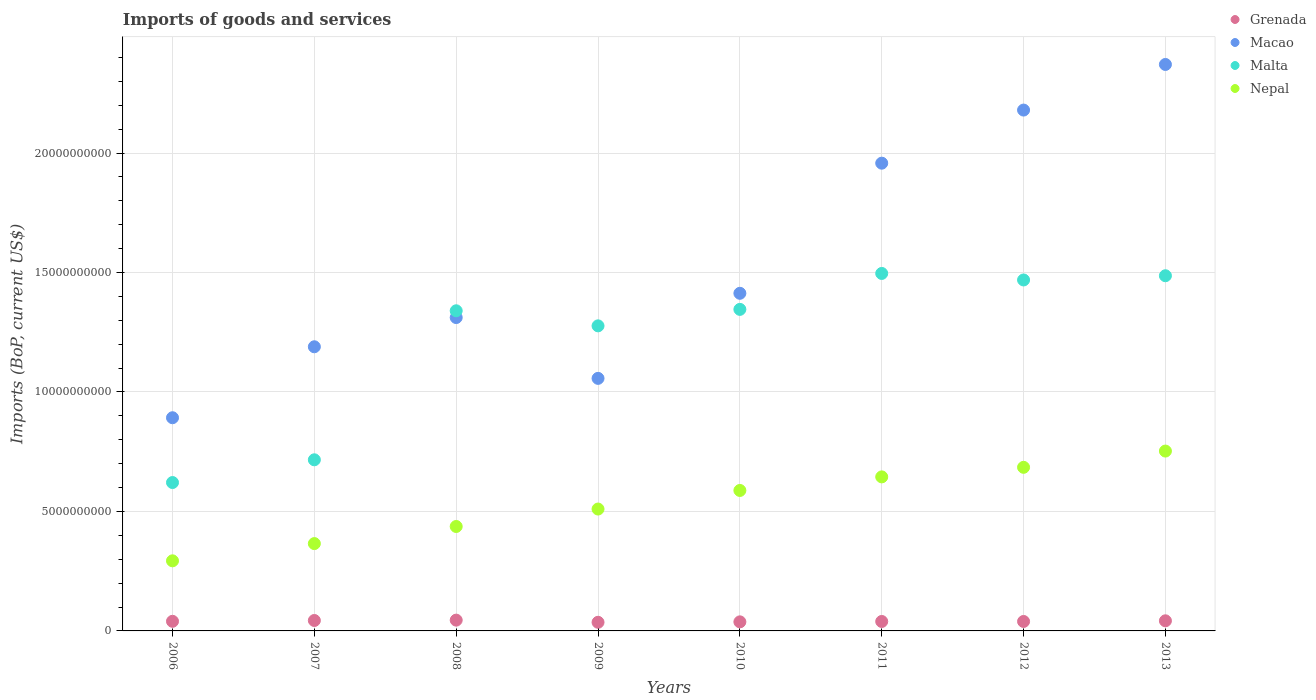Is the number of dotlines equal to the number of legend labels?
Give a very brief answer. Yes. What is the amount spent on imports in Macao in 2006?
Your answer should be compact. 8.92e+09. Across all years, what is the maximum amount spent on imports in Grenada?
Keep it short and to the point. 4.52e+08. Across all years, what is the minimum amount spent on imports in Macao?
Provide a short and direct response. 8.92e+09. In which year was the amount spent on imports in Macao maximum?
Give a very brief answer. 2013. What is the total amount spent on imports in Malta in the graph?
Offer a terse response. 9.75e+1. What is the difference between the amount spent on imports in Malta in 2008 and that in 2011?
Your response must be concise. -1.56e+09. What is the difference between the amount spent on imports in Nepal in 2011 and the amount spent on imports in Malta in 2013?
Provide a succinct answer. -8.42e+09. What is the average amount spent on imports in Malta per year?
Offer a terse response. 1.22e+1. In the year 2007, what is the difference between the amount spent on imports in Macao and amount spent on imports in Malta?
Keep it short and to the point. 4.73e+09. What is the ratio of the amount spent on imports in Grenada in 2010 to that in 2012?
Offer a terse response. 0.96. Is the amount spent on imports in Malta in 2008 less than that in 2012?
Provide a short and direct response. Yes. Is the difference between the amount spent on imports in Macao in 2008 and 2011 greater than the difference between the amount spent on imports in Malta in 2008 and 2011?
Ensure brevity in your answer.  No. What is the difference between the highest and the second highest amount spent on imports in Malta?
Provide a succinct answer. 9.62e+07. What is the difference between the highest and the lowest amount spent on imports in Malta?
Your response must be concise. 8.75e+09. Is it the case that in every year, the sum of the amount spent on imports in Grenada and amount spent on imports in Nepal  is greater than the amount spent on imports in Malta?
Ensure brevity in your answer.  No. Does the amount spent on imports in Malta monotonically increase over the years?
Give a very brief answer. No. What is the difference between two consecutive major ticks on the Y-axis?
Provide a succinct answer. 5.00e+09. Does the graph contain any zero values?
Your response must be concise. No. How are the legend labels stacked?
Make the answer very short. Vertical. What is the title of the graph?
Give a very brief answer. Imports of goods and services. What is the label or title of the Y-axis?
Your answer should be compact. Imports (BoP, current US$). What is the Imports (BoP, current US$) of Grenada in 2006?
Make the answer very short. 4.02e+08. What is the Imports (BoP, current US$) in Macao in 2006?
Your response must be concise. 8.92e+09. What is the Imports (BoP, current US$) in Malta in 2006?
Provide a short and direct response. 6.21e+09. What is the Imports (BoP, current US$) in Nepal in 2006?
Give a very brief answer. 2.93e+09. What is the Imports (BoP, current US$) in Grenada in 2007?
Ensure brevity in your answer.  4.36e+08. What is the Imports (BoP, current US$) in Macao in 2007?
Your answer should be compact. 1.19e+1. What is the Imports (BoP, current US$) in Malta in 2007?
Give a very brief answer. 7.16e+09. What is the Imports (BoP, current US$) of Nepal in 2007?
Provide a succinct answer. 3.66e+09. What is the Imports (BoP, current US$) of Grenada in 2008?
Provide a succinct answer. 4.52e+08. What is the Imports (BoP, current US$) in Macao in 2008?
Ensure brevity in your answer.  1.31e+1. What is the Imports (BoP, current US$) of Malta in 2008?
Keep it short and to the point. 1.34e+1. What is the Imports (BoP, current US$) in Nepal in 2008?
Your answer should be compact. 4.37e+09. What is the Imports (BoP, current US$) of Grenada in 2009?
Provide a short and direct response. 3.61e+08. What is the Imports (BoP, current US$) of Macao in 2009?
Make the answer very short. 1.06e+1. What is the Imports (BoP, current US$) of Malta in 2009?
Ensure brevity in your answer.  1.28e+1. What is the Imports (BoP, current US$) of Nepal in 2009?
Offer a terse response. 5.10e+09. What is the Imports (BoP, current US$) of Grenada in 2010?
Keep it short and to the point. 3.80e+08. What is the Imports (BoP, current US$) in Macao in 2010?
Your answer should be compact. 1.41e+1. What is the Imports (BoP, current US$) of Malta in 2010?
Provide a short and direct response. 1.35e+1. What is the Imports (BoP, current US$) of Nepal in 2010?
Your answer should be compact. 5.88e+09. What is the Imports (BoP, current US$) in Grenada in 2011?
Your response must be concise. 3.95e+08. What is the Imports (BoP, current US$) of Macao in 2011?
Give a very brief answer. 1.96e+1. What is the Imports (BoP, current US$) in Malta in 2011?
Provide a succinct answer. 1.50e+1. What is the Imports (BoP, current US$) of Nepal in 2011?
Keep it short and to the point. 6.45e+09. What is the Imports (BoP, current US$) of Grenada in 2012?
Offer a very short reply. 3.96e+08. What is the Imports (BoP, current US$) of Macao in 2012?
Offer a terse response. 2.18e+1. What is the Imports (BoP, current US$) in Malta in 2012?
Provide a succinct answer. 1.47e+1. What is the Imports (BoP, current US$) in Nepal in 2012?
Ensure brevity in your answer.  6.85e+09. What is the Imports (BoP, current US$) of Grenada in 2013?
Offer a very short reply. 4.23e+08. What is the Imports (BoP, current US$) of Macao in 2013?
Offer a terse response. 2.37e+1. What is the Imports (BoP, current US$) of Malta in 2013?
Ensure brevity in your answer.  1.49e+1. What is the Imports (BoP, current US$) of Nepal in 2013?
Your answer should be compact. 7.53e+09. Across all years, what is the maximum Imports (BoP, current US$) of Grenada?
Give a very brief answer. 4.52e+08. Across all years, what is the maximum Imports (BoP, current US$) of Macao?
Offer a terse response. 2.37e+1. Across all years, what is the maximum Imports (BoP, current US$) of Malta?
Keep it short and to the point. 1.50e+1. Across all years, what is the maximum Imports (BoP, current US$) in Nepal?
Offer a terse response. 7.53e+09. Across all years, what is the minimum Imports (BoP, current US$) in Grenada?
Ensure brevity in your answer.  3.61e+08. Across all years, what is the minimum Imports (BoP, current US$) in Macao?
Ensure brevity in your answer.  8.92e+09. Across all years, what is the minimum Imports (BoP, current US$) of Malta?
Offer a terse response. 6.21e+09. Across all years, what is the minimum Imports (BoP, current US$) of Nepal?
Give a very brief answer. 2.93e+09. What is the total Imports (BoP, current US$) of Grenada in the graph?
Your response must be concise. 3.25e+09. What is the total Imports (BoP, current US$) of Macao in the graph?
Your answer should be compact. 1.24e+11. What is the total Imports (BoP, current US$) of Malta in the graph?
Your answer should be compact. 9.75e+1. What is the total Imports (BoP, current US$) of Nepal in the graph?
Give a very brief answer. 4.28e+1. What is the difference between the Imports (BoP, current US$) in Grenada in 2006 and that in 2007?
Your response must be concise. -3.40e+07. What is the difference between the Imports (BoP, current US$) of Macao in 2006 and that in 2007?
Offer a terse response. -2.97e+09. What is the difference between the Imports (BoP, current US$) of Malta in 2006 and that in 2007?
Give a very brief answer. -9.52e+08. What is the difference between the Imports (BoP, current US$) in Nepal in 2006 and that in 2007?
Ensure brevity in your answer.  -7.21e+08. What is the difference between the Imports (BoP, current US$) of Grenada in 2006 and that in 2008?
Provide a short and direct response. -4.93e+07. What is the difference between the Imports (BoP, current US$) of Macao in 2006 and that in 2008?
Provide a short and direct response. -4.19e+09. What is the difference between the Imports (BoP, current US$) of Malta in 2006 and that in 2008?
Provide a short and direct response. -7.19e+09. What is the difference between the Imports (BoP, current US$) of Nepal in 2006 and that in 2008?
Provide a short and direct response. -1.44e+09. What is the difference between the Imports (BoP, current US$) in Grenada in 2006 and that in 2009?
Provide a short and direct response. 4.14e+07. What is the difference between the Imports (BoP, current US$) of Macao in 2006 and that in 2009?
Ensure brevity in your answer.  -1.65e+09. What is the difference between the Imports (BoP, current US$) in Malta in 2006 and that in 2009?
Make the answer very short. -6.56e+09. What is the difference between the Imports (BoP, current US$) in Nepal in 2006 and that in 2009?
Keep it short and to the point. -2.17e+09. What is the difference between the Imports (BoP, current US$) in Grenada in 2006 and that in 2010?
Make the answer very short. 2.28e+07. What is the difference between the Imports (BoP, current US$) of Macao in 2006 and that in 2010?
Your answer should be compact. -5.21e+09. What is the difference between the Imports (BoP, current US$) of Malta in 2006 and that in 2010?
Your response must be concise. -7.25e+09. What is the difference between the Imports (BoP, current US$) in Nepal in 2006 and that in 2010?
Provide a succinct answer. -2.94e+09. What is the difference between the Imports (BoP, current US$) in Grenada in 2006 and that in 2011?
Offer a terse response. 6.90e+06. What is the difference between the Imports (BoP, current US$) of Macao in 2006 and that in 2011?
Make the answer very short. -1.07e+1. What is the difference between the Imports (BoP, current US$) in Malta in 2006 and that in 2011?
Provide a succinct answer. -8.75e+09. What is the difference between the Imports (BoP, current US$) in Nepal in 2006 and that in 2011?
Your answer should be very brief. -3.51e+09. What is the difference between the Imports (BoP, current US$) in Grenada in 2006 and that in 2012?
Your answer should be compact. 6.71e+06. What is the difference between the Imports (BoP, current US$) in Macao in 2006 and that in 2012?
Make the answer very short. -1.29e+1. What is the difference between the Imports (BoP, current US$) in Malta in 2006 and that in 2012?
Offer a very short reply. -8.48e+09. What is the difference between the Imports (BoP, current US$) of Nepal in 2006 and that in 2012?
Offer a terse response. -3.91e+09. What is the difference between the Imports (BoP, current US$) of Grenada in 2006 and that in 2013?
Your response must be concise. -2.08e+07. What is the difference between the Imports (BoP, current US$) in Macao in 2006 and that in 2013?
Offer a terse response. -1.48e+1. What is the difference between the Imports (BoP, current US$) in Malta in 2006 and that in 2013?
Offer a very short reply. -8.66e+09. What is the difference between the Imports (BoP, current US$) of Nepal in 2006 and that in 2013?
Ensure brevity in your answer.  -4.59e+09. What is the difference between the Imports (BoP, current US$) of Grenada in 2007 and that in 2008?
Offer a terse response. -1.53e+07. What is the difference between the Imports (BoP, current US$) in Macao in 2007 and that in 2008?
Provide a succinct answer. -1.22e+09. What is the difference between the Imports (BoP, current US$) in Malta in 2007 and that in 2008?
Ensure brevity in your answer.  -6.24e+09. What is the difference between the Imports (BoP, current US$) in Nepal in 2007 and that in 2008?
Provide a short and direct response. -7.16e+08. What is the difference between the Imports (BoP, current US$) of Grenada in 2007 and that in 2009?
Your answer should be very brief. 7.54e+07. What is the difference between the Imports (BoP, current US$) in Macao in 2007 and that in 2009?
Offer a very short reply. 1.32e+09. What is the difference between the Imports (BoP, current US$) in Malta in 2007 and that in 2009?
Give a very brief answer. -5.61e+09. What is the difference between the Imports (BoP, current US$) in Nepal in 2007 and that in 2009?
Make the answer very short. -1.45e+09. What is the difference between the Imports (BoP, current US$) of Grenada in 2007 and that in 2010?
Your response must be concise. 5.68e+07. What is the difference between the Imports (BoP, current US$) in Macao in 2007 and that in 2010?
Provide a succinct answer. -2.24e+09. What is the difference between the Imports (BoP, current US$) in Malta in 2007 and that in 2010?
Provide a short and direct response. -6.30e+09. What is the difference between the Imports (BoP, current US$) in Nepal in 2007 and that in 2010?
Offer a very short reply. -2.22e+09. What is the difference between the Imports (BoP, current US$) in Grenada in 2007 and that in 2011?
Your answer should be very brief. 4.09e+07. What is the difference between the Imports (BoP, current US$) in Macao in 2007 and that in 2011?
Ensure brevity in your answer.  -7.68e+09. What is the difference between the Imports (BoP, current US$) in Malta in 2007 and that in 2011?
Provide a succinct answer. -7.80e+09. What is the difference between the Imports (BoP, current US$) in Nepal in 2007 and that in 2011?
Your answer should be compact. -2.79e+09. What is the difference between the Imports (BoP, current US$) in Grenada in 2007 and that in 2012?
Provide a short and direct response. 4.07e+07. What is the difference between the Imports (BoP, current US$) in Macao in 2007 and that in 2012?
Offer a terse response. -9.91e+09. What is the difference between the Imports (BoP, current US$) in Malta in 2007 and that in 2012?
Make the answer very short. -7.53e+09. What is the difference between the Imports (BoP, current US$) in Nepal in 2007 and that in 2012?
Your response must be concise. -3.19e+09. What is the difference between the Imports (BoP, current US$) in Grenada in 2007 and that in 2013?
Keep it short and to the point. 1.32e+07. What is the difference between the Imports (BoP, current US$) of Macao in 2007 and that in 2013?
Ensure brevity in your answer.  -1.18e+1. What is the difference between the Imports (BoP, current US$) of Malta in 2007 and that in 2013?
Ensure brevity in your answer.  -7.70e+09. What is the difference between the Imports (BoP, current US$) of Nepal in 2007 and that in 2013?
Provide a succinct answer. -3.87e+09. What is the difference between the Imports (BoP, current US$) in Grenada in 2008 and that in 2009?
Ensure brevity in your answer.  9.08e+07. What is the difference between the Imports (BoP, current US$) of Macao in 2008 and that in 2009?
Offer a terse response. 2.55e+09. What is the difference between the Imports (BoP, current US$) in Malta in 2008 and that in 2009?
Make the answer very short. 6.31e+08. What is the difference between the Imports (BoP, current US$) of Nepal in 2008 and that in 2009?
Give a very brief answer. -7.30e+08. What is the difference between the Imports (BoP, current US$) of Grenada in 2008 and that in 2010?
Give a very brief answer. 7.22e+07. What is the difference between the Imports (BoP, current US$) of Macao in 2008 and that in 2010?
Offer a terse response. -1.01e+09. What is the difference between the Imports (BoP, current US$) of Malta in 2008 and that in 2010?
Offer a terse response. -5.88e+07. What is the difference between the Imports (BoP, current US$) of Nepal in 2008 and that in 2010?
Keep it short and to the point. -1.51e+09. What is the difference between the Imports (BoP, current US$) in Grenada in 2008 and that in 2011?
Ensure brevity in your answer.  5.62e+07. What is the difference between the Imports (BoP, current US$) in Macao in 2008 and that in 2011?
Your response must be concise. -6.46e+09. What is the difference between the Imports (BoP, current US$) in Malta in 2008 and that in 2011?
Provide a short and direct response. -1.56e+09. What is the difference between the Imports (BoP, current US$) of Nepal in 2008 and that in 2011?
Offer a very short reply. -2.08e+09. What is the difference between the Imports (BoP, current US$) of Grenada in 2008 and that in 2012?
Offer a terse response. 5.60e+07. What is the difference between the Imports (BoP, current US$) in Macao in 2008 and that in 2012?
Provide a succinct answer. -8.68e+09. What is the difference between the Imports (BoP, current US$) in Malta in 2008 and that in 2012?
Your response must be concise. -1.29e+09. What is the difference between the Imports (BoP, current US$) in Nepal in 2008 and that in 2012?
Offer a very short reply. -2.48e+09. What is the difference between the Imports (BoP, current US$) of Grenada in 2008 and that in 2013?
Your answer should be compact. 2.85e+07. What is the difference between the Imports (BoP, current US$) of Macao in 2008 and that in 2013?
Ensure brevity in your answer.  -1.06e+1. What is the difference between the Imports (BoP, current US$) of Malta in 2008 and that in 2013?
Your answer should be very brief. -1.47e+09. What is the difference between the Imports (BoP, current US$) of Nepal in 2008 and that in 2013?
Make the answer very short. -3.16e+09. What is the difference between the Imports (BoP, current US$) of Grenada in 2009 and that in 2010?
Your answer should be very brief. -1.86e+07. What is the difference between the Imports (BoP, current US$) of Macao in 2009 and that in 2010?
Your response must be concise. -3.56e+09. What is the difference between the Imports (BoP, current US$) in Malta in 2009 and that in 2010?
Provide a succinct answer. -6.89e+08. What is the difference between the Imports (BoP, current US$) in Nepal in 2009 and that in 2010?
Your answer should be compact. -7.78e+08. What is the difference between the Imports (BoP, current US$) in Grenada in 2009 and that in 2011?
Your answer should be very brief. -3.45e+07. What is the difference between the Imports (BoP, current US$) in Macao in 2009 and that in 2011?
Your response must be concise. -9.01e+09. What is the difference between the Imports (BoP, current US$) of Malta in 2009 and that in 2011?
Provide a succinct answer. -2.19e+09. What is the difference between the Imports (BoP, current US$) in Nepal in 2009 and that in 2011?
Your answer should be very brief. -1.35e+09. What is the difference between the Imports (BoP, current US$) of Grenada in 2009 and that in 2012?
Provide a short and direct response. -3.47e+07. What is the difference between the Imports (BoP, current US$) in Macao in 2009 and that in 2012?
Your answer should be very brief. -1.12e+1. What is the difference between the Imports (BoP, current US$) of Malta in 2009 and that in 2012?
Your answer should be compact. -1.92e+09. What is the difference between the Imports (BoP, current US$) in Nepal in 2009 and that in 2012?
Your answer should be very brief. -1.75e+09. What is the difference between the Imports (BoP, current US$) in Grenada in 2009 and that in 2013?
Your response must be concise. -6.23e+07. What is the difference between the Imports (BoP, current US$) of Macao in 2009 and that in 2013?
Provide a succinct answer. -1.31e+1. What is the difference between the Imports (BoP, current US$) in Malta in 2009 and that in 2013?
Offer a very short reply. -2.10e+09. What is the difference between the Imports (BoP, current US$) of Nepal in 2009 and that in 2013?
Make the answer very short. -2.43e+09. What is the difference between the Imports (BoP, current US$) in Grenada in 2010 and that in 2011?
Provide a succinct answer. -1.59e+07. What is the difference between the Imports (BoP, current US$) in Macao in 2010 and that in 2011?
Offer a terse response. -5.45e+09. What is the difference between the Imports (BoP, current US$) of Malta in 2010 and that in 2011?
Provide a short and direct response. -1.50e+09. What is the difference between the Imports (BoP, current US$) of Nepal in 2010 and that in 2011?
Provide a short and direct response. -5.68e+08. What is the difference between the Imports (BoP, current US$) of Grenada in 2010 and that in 2012?
Ensure brevity in your answer.  -1.61e+07. What is the difference between the Imports (BoP, current US$) of Macao in 2010 and that in 2012?
Make the answer very short. -7.67e+09. What is the difference between the Imports (BoP, current US$) in Malta in 2010 and that in 2012?
Offer a very short reply. -1.23e+09. What is the difference between the Imports (BoP, current US$) of Nepal in 2010 and that in 2012?
Ensure brevity in your answer.  -9.69e+08. What is the difference between the Imports (BoP, current US$) of Grenada in 2010 and that in 2013?
Your answer should be compact. -4.37e+07. What is the difference between the Imports (BoP, current US$) of Macao in 2010 and that in 2013?
Your response must be concise. -9.58e+09. What is the difference between the Imports (BoP, current US$) of Malta in 2010 and that in 2013?
Provide a short and direct response. -1.41e+09. What is the difference between the Imports (BoP, current US$) in Nepal in 2010 and that in 2013?
Keep it short and to the point. -1.65e+09. What is the difference between the Imports (BoP, current US$) of Grenada in 2011 and that in 2012?
Provide a succinct answer. -1.89e+05. What is the difference between the Imports (BoP, current US$) of Macao in 2011 and that in 2012?
Keep it short and to the point. -2.22e+09. What is the difference between the Imports (BoP, current US$) in Malta in 2011 and that in 2012?
Ensure brevity in your answer.  2.73e+08. What is the difference between the Imports (BoP, current US$) of Nepal in 2011 and that in 2012?
Ensure brevity in your answer.  -4.00e+08. What is the difference between the Imports (BoP, current US$) of Grenada in 2011 and that in 2013?
Your response must be concise. -2.77e+07. What is the difference between the Imports (BoP, current US$) of Macao in 2011 and that in 2013?
Make the answer very short. -4.13e+09. What is the difference between the Imports (BoP, current US$) in Malta in 2011 and that in 2013?
Provide a short and direct response. 9.62e+07. What is the difference between the Imports (BoP, current US$) of Nepal in 2011 and that in 2013?
Provide a short and direct response. -1.08e+09. What is the difference between the Imports (BoP, current US$) in Grenada in 2012 and that in 2013?
Keep it short and to the point. -2.76e+07. What is the difference between the Imports (BoP, current US$) of Macao in 2012 and that in 2013?
Your response must be concise. -1.91e+09. What is the difference between the Imports (BoP, current US$) in Malta in 2012 and that in 2013?
Provide a succinct answer. -1.77e+08. What is the difference between the Imports (BoP, current US$) of Nepal in 2012 and that in 2013?
Offer a terse response. -6.80e+08. What is the difference between the Imports (BoP, current US$) in Grenada in 2006 and the Imports (BoP, current US$) in Macao in 2007?
Provide a succinct answer. -1.15e+1. What is the difference between the Imports (BoP, current US$) in Grenada in 2006 and the Imports (BoP, current US$) in Malta in 2007?
Make the answer very short. -6.76e+09. What is the difference between the Imports (BoP, current US$) in Grenada in 2006 and the Imports (BoP, current US$) in Nepal in 2007?
Provide a succinct answer. -3.25e+09. What is the difference between the Imports (BoP, current US$) in Macao in 2006 and the Imports (BoP, current US$) in Malta in 2007?
Offer a very short reply. 1.76e+09. What is the difference between the Imports (BoP, current US$) in Macao in 2006 and the Imports (BoP, current US$) in Nepal in 2007?
Your answer should be compact. 5.27e+09. What is the difference between the Imports (BoP, current US$) of Malta in 2006 and the Imports (BoP, current US$) of Nepal in 2007?
Your response must be concise. 2.56e+09. What is the difference between the Imports (BoP, current US$) of Grenada in 2006 and the Imports (BoP, current US$) of Macao in 2008?
Provide a succinct answer. -1.27e+1. What is the difference between the Imports (BoP, current US$) of Grenada in 2006 and the Imports (BoP, current US$) of Malta in 2008?
Provide a succinct answer. -1.30e+1. What is the difference between the Imports (BoP, current US$) in Grenada in 2006 and the Imports (BoP, current US$) in Nepal in 2008?
Offer a very short reply. -3.97e+09. What is the difference between the Imports (BoP, current US$) in Macao in 2006 and the Imports (BoP, current US$) in Malta in 2008?
Give a very brief answer. -4.48e+09. What is the difference between the Imports (BoP, current US$) in Macao in 2006 and the Imports (BoP, current US$) in Nepal in 2008?
Ensure brevity in your answer.  4.55e+09. What is the difference between the Imports (BoP, current US$) in Malta in 2006 and the Imports (BoP, current US$) in Nepal in 2008?
Your answer should be very brief. 1.84e+09. What is the difference between the Imports (BoP, current US$) of Grenada in 2006 and the Imports (BoP, current US$) of Macao in 2009?
Your answer should be very brief. -1.02e+1. What is the difference between the Imports (BoP, current US$) of Grenada in 2006 and the Imports (BoP, current US$) of Malta in 2009?
Give a very brief answer. -1.24e+1. What is the difference between the Imports (BoP, current US$) in Grenada in 2006 and the Imports (BoP, current US$) in Nepal in 2009?
Make the answer very short. -4.70e+09. What is the difference between the Imports (BoP, current US$) of Macao in 2006 and the Imports (BoP, current US$) of Malta in 2009?
Provide a short and direct response. -3.85e+09. What is the difference between the Imports (BoP, current US$) in Macao in 2006 and the Imports (BoP, current US$) in Nepal in 2009?
Your answer should be very brief. 3.82e+09. What is the difference between the Imports (BoP, current US$) in Malta in 2006 and the Imports (BoP, current US$) in Nepal in 2009?
Offer a very short reply. 1.11e+09. What is the difference between the Imports (BoP, current US$) of Grenada in 2006 and the Imports (BoP, current US$) of Macao in 2010?
Offer a very short reply. -1.37e+1. What is the difference between the Imports (BoP, current US$) in Grenada in 2006 and the Imports (BoP, current US$) in Malta in 2010?
Your answer should be very brief. -1.31e+1. What is the difference between the Imports (BoP, current US$) in Grenada in 2006 and the Imports (BoP, current US$) in Nepal in 2010?
Your response must be concise. -5.48e+09. What is the difference between the Imports (BoP, current US$) in Macao in 2006 and the Imports (BoP, current US$) in Malta in 2010?
Keep it short and to the point. -4.54e+09. What is the difference between the Imports (BoP, current US$) of Macao in 2006 and the Imports (BoP, current US$) of Nepal in 2010?
Provide a short and direct response. 3.04e+09. What is the difference between the Imports (BoP, current US$) in Malta in 2006 and the Imports (BoP, current US$) in Nepal in 2010?
Offer a very short reply. 3.32e+08. What is the difference between the Imports (BoP, current US$) in Grenada in 2006 and the Imports (BoP, current US$) in Macao in 2011?
Your response must be concise. -1.92e+1. What is the difference between the Imports (BoP, current US$) in Grenada in 2006 and the Imports (BoP, current US$) in Malta in 2011?
Your response must be concise. -1.46e+1. What is the difference between the Imports (BoP, current US$) of Grenada in 2006 and the Imports (BoP, current US$) of Nepal in 2011?
Give a very brief answer. -6.04e+09. What is the difference between the Imports (BoP, current US$) in Macao in 2006 and the Imports (BoP, current US$) in Malta in 2011?
Your answer should be very brief. -6.04e+09. What is the difference between the Imports (BoP, current US$) of Macao in 2006 and the Imports (BoP, current US$) of Nepal in 2011?
Provide a short and direct response. 2.48e+09. What is the difference between the Imports (BoP, current US$) of Malta in 2006 and the Imports (BoP, current US$) of Nepal in 2011?
Give a very brief answer. -2.37e+08. What is the difference between the Imports (BoP, current US$) of Grenada in 2006 and the Imports (BoP, current US$) of Macao in 2012?
Offer a very short reply. -2.14e+1. What is the difference between the Imports (BoP, current US$) of Grenada in 2006 and the Imports (BoP, current US$) of Malta in 2012?
Keep it short and to the point. -1.43e+1. What is the difference between the Imports (BoP, current US$) of Grenada in 2006 and the Imports (BoP, current US$) of Nepal in 2012?
Give a very brief answer. -6.45e+09. What is the difference between the Imports (BoP, current US$) of Macao in 2006 and the Imports (BoP, current US$) of Malta in 2012?
Provide a short and direct response. -5.77e+09. What is the difference between the Imports (BoP, current US$) in Macao in 2006 and the Imports (BoP, current US$) in Nepal in 2012?
Your answer should be very brief. 2.07e+09. What is the difference between the Imports (BoP, current US$) of Malta in 2006 and the Imports (BoP, current US$) of Nepal in 2012?
Make the answer very short. -6.37e+08. What is the difference between the Imports (BoP, current US$) in Grenada in 2006 and the Imports (BoP, current US$) in Macao in 2013?
Offer a very short reply. -2.33e+1. What is the difference between the Imports (BoP, current US$) of Grenada in 2006 and the Imports (BoP, current US$) of Malta in 2013?
Ensure brevity in your answer.  -1.45e+1. What is the difference between the Imports (BoP, current US$) of Grenada in 2006 and the Imports (BoP, current US$) of Nepal in 2013?
Keep it short and to the point. -7.13e+09. What is the difference between the Imports (BoP, current US$) of Macao in 2006 and the Imports (BoP, current US$) of Malta in 2013?
Offer a terse response. -5.94e+09. What is the difference between the Imports (BoP, current US$) of Macao in 2006 and the Imports (BoP, current US$) of Nepal in 2013?
Provide a short and direct response. 1.39e+09. What is the difference between the Imports (BoP, current US$) of Malta in 2006 and the Imports (BoP, current US$) of Nepal in 2013?
Offer a very short reply. -1.32e+09. What is the difference between the Imports (BoP, current US$) of Grenada in 2007 and the Imports (BoP, current US$) of Macao in 2008?
Provide a succinct answer. -1.27e+1. What is the difference between the Imports (BoP, current US$) of Grenada in 2007 and the Imports (BoP, current US$) of Malta in 2008?
Your answer should be compact. -1.30e+1. What is the difference between the Imports (BoP, current US$) of Grenada in 2007 and the Imports (BoP, current US$) of Nepal in 2008?
Provide a succinct answer. -3.93e+09. What is the difference between the Imports (BoP, current US$) of Macao in 2007 and the Imports (BoP, current US$) of Malta in 2008?
Your response must be concise. -1.51e+09. What is the difference between the Imports (BoP, current US$) in Macao in 2007 and the Imports (BoP, current US$) in Nepal in 2008?
Make the answer very short. 7.52e+09. What is the difference between the Imports (BoP, current US$) in Malta in 2007 and the Imports (BoP, current US$) in Nepal in 2008?
Give a very brief answer. 2.79e+09. What is the difference between the Imports (BoP, current US$) in Grenada in 2007 and the Imports (BoP, current US$) in Macao in 2009?
Provide a succinct answer. -1.01e+1. What is the difference between the Imports (BoP, current US$) in Grenada in 2007 and the Imports (BoP, current US$) in Malta in 2009?
Offer a very short reply. -1.23e+1. What is the difference between the Imports (BoP, current US$) in Grenada in 2007 and the Imports (BoP, current US$) in Nepal in 2009?
Offer a very short reply. -4.66e+09. What is the difference between the Imports (BoP, current US$) in Macao in 2007 and the Imports (BoP, current US$) in Malta in 2009?
Make the answer very short. -8.75e+08. What is the difference between the Imports (BoP, current US$) in Macao in 2007 and the Imports (BoP, current US$) in Nepal in 2009?
Ensure brevity in your answer.  6.79e+09. What is the difference between the Imports (BoP, current US$) of Malta in 2007 and the Imports (BoP, current US$) of Nepal in 2009?
Provide a short and direct response. 2.06e+09. What is the difference between the Imports (BoP, current US$) in Grenada in 2007 and the Imports (BoP, current US$) in Macao in 2010?
Your response must be concise. -1.37e+1. What is the difference between the Imports (BoP, current US$) in Grenada in 2007 and the Imports (BoP, current US$) in Malta in 2010?
Offer a terse response. -1.30e+1. What is the difference between the Imports (BoP, current US$) in Grenada in 2007 and the Imports (BoP, current US$) in Nepal in 2010?
Offer a terse response. -5.44e+09. What is the difference between the Imports (BoP, current US$) in Macao in 2007 and the Imports (BoP, current US$) in Malta in 2010?
Offer a terse response. -1.56e+09. What is the difference between the Imports (BoP, current US$) in Macao in 2007 and the Imports (BoP, current US$) in Nepal in 2010?
Provide a short and direct response. 6.01e+09. What is the difference between the Imports (BoP, current US$) of Malta in 2007 and the Imports (BoP, current US$) of Nepal in 2010?
Offer a terse response. 1.28e+09. What is the difference between the Imports (BoP, current US$) in Grenada in 2007 and the Imports (BoP, current US$) in Macao in 2011?
Provide a short and direct response. -1.91e+1. What is the difference between the Imports (BoP, current US$) of Grenada in 2007 and the Imports (BoP, current US$) of Malta in 2011?
Keep it short and to the point. -1.45e+1. What is the difference between the Imports (BoP, current US$) of Grenada in 2007 and the Imports (BoP, current US$) of Nepal in 2011?
Give a very brief answer. -6.01e+09. What is the difference between the Imports (BoP, current US$) in Macao in 2007 and the Imports (BoP, current US$) in Malta in 2011?
Provide a succinct answer. -3.07e+09. What is the difference between the Imports (BoP, current US$) in Macao in 2007 and the Imports (BoP, current US$) in Nepal in 2011?
Provide a succinct answer. 5.45e+09. What is the difference between the Imports (BoP, current US$) of Malta in 2007 and the Imports (BoP, current US$) of Nepal in 2011?
Provide a succinct answer. 7.15e+08. What is the difference between the Imports (BoP, current US$) in Grenada in 2007 and the Imports (BoP, current US$) in Macao in 2012?
Offer a terse response. -2.14e+1. What is the difference between the Imports (BoP, current US$) in Grenada in 2007 and the Imports (BoP, current US$) in Malta in 2012?
Give a very brief answer. -1.43e+1. What is the difference between the Imports (BoP, current US$) in Grenada in 2007 and the Imports (BoP, current US$) in Nepal in 2012?
Keep it short and to the point. -6.41e+09. What is the difference between the Imports (BoP, current US$) in Macao in 2007 and the Imports (BoP, current US$) in Malta in 2012?
Your answer should be very brief. -2.80e+09. What is the difference between the Imports (BoP, current US$) of Macao in 2007 and the Imports (BoP, current US$) of Nepal in 2012?
Give a very brief answer. 5.05e+09. What is the difference between the Imports (BoP, current US$) of Malta in 2007 and the Imports (BoP, current US$) of Nepal in 2012?
Your answer should be very brief. 3.15e+08. What is the difference between the Imports (BoP, current US$) of Grenada in 2007 and the Imports (BoP, current US$) of Macao in 2013?
Provide a short and direct response. -2.33e+1. What is the difference between the Imports (BoP, current US$) of Grenada in 2007 and the Imports (BoP, current US$) of Malta in 2013?
Ensure brevity in your answer.  -1.44e+1. What is the difference between the Imports (BoP, current US$) in Grenada in 2007 and the Imports (BoP, current US$) in Nepal in 2013?
Make the answer very short. -7.09e+09. What is the difference between the Imports (BoP, current US$) of Macao in 2007 and the Imports (BoP, current US$) of Malta in 2013?
Your answer should be very brief. -2.97e+09. What is the difference between the Imports (BoP, current US$) in Macao in 2007 and the Imports (BoP, current US$) in Nepal in 2013?
Your response must be concise. 4.37e+09. What is the difference between the Imports (BoP, current US$) in Malta in 2007 and the Imports (BoP, current US$) in Nepal in 2013?
Provide a succinct answer. -3.66e+08. What is the difference between the Imports (BoP, current US$) in Grenada in 2008 and the Imports (BoP, current US$) in Macao in 2009?
Keep it short and to the point. -1.01e+1. What is the difference between the Imports (BoP, current US$) of Grenada in 2008 and the Imports (BoP, current US$) of Malta in 2009?
Your answer should be very brief. -1.23e+1. What is the difference between the Imports (BoP, current US$) in Grenada in 2008 and the Imports (BoP, current US$) in Nepal in 2009?
Provide a succinct answer. -4.65e+09. What is the difference between the Imports (BoP, current US$) in Macao in 2008 and the Imports (BoP, current US$) in Malta in 2009?
Give a very brief answer. 3.48e+08. What is the difference between the Imports (BoP, current US$) in Macao in 2008 and the Imports (BoP, current US$) in Nepal in 2009?
Make the answer very short. 8.01e+09. What is the difference between the Imports (BoP, current US$) of Malta in 2008 and the Imports (BoP, current US$) of Nepal in 2009?
Offer a very short reply. 8.30e+09. What is the difference between the Imports (BoP, current US$) in Grenada in 2008 and the Imports (BoP, current US$) in Macao in 2010?
Offer a very short reply. -1.37e+1. What is the difference between the Imports (BoP, current US$) in Grenada in 2008 and the Imports (BoP, current US$) in Malta in 2010?
Your response must be concise. -1.30e+1. What is the difference between the Imports (BoP, current US$) of Grenada in 2008 and the Imports (BoP, current US$) of Nepal in 2010?
Keep it short and to the point. -5.43e+09. What is the difference between the Imports (BoP, current US$) in Macao in 2008 and the Imports (BoP, current US$) in Malta in 2010?
Offer a terse response. -3.42e+08. What is the difference between the Imports (BoP, current US$) in Macao in 2008 and the Imports (BoP, current US$) in Nepal in 2010?
Offer a very short reply. 7.24e+09. What is the difference between the Imports (BoP, current US$) of Malta in 2008 and the Imports (BoP, current US$) of Nepal in 2010?
Your answer should be compact. 7.52e+09. What is the difference between the Imports (BoP, current US$) of Grenada in 2008 and the Imports (BoP, current US$) of Macao in 2011?
Keep it short and to the point. -1.91e+1. What is the difference between the Imports (BoP, current US$) of Grenada in 2008 and the Imports (BoP, current US$) of Malta in 2011?
Provide a succinct answer. -1.45e+1. What is the difference between the Imports (BoP, current US$) of Grenada in 2008 and the Imports (BoP, current US$) of Nepal in 2011?
Your answer should be very brief. -6.00e+09. What is the difference between the Imports (BoP, current US$) of Macao in 2008 and the Imports (BoP, current US$) of Malta in 2011?
Ensure brevity in your answer.  -1.85e+09. What is the difference between the Imports (BoP, current US$) in Macao in 2008 and the Imports (BoP, current US$) in Nepal in 2011?
Keep it short and to the point. 6.67e+09. What is the difference between the Imports (BoP, current US$) in Malta in 2008 and the Imports (BoP, current US$) in Nepal in 2011?
Your answer should be compact. 6.95e+09. What is the difference between the Imports (BoP, current US$) in Grenada in 2008 and the Imports (BoP, current US$) in Macao in 2012?
Ensure brevity in your answer.  -2.13e+1. What is the difference between the Imports (BoP, current US$) of Grenada in 2008 and the Imports (BoP, current US$) of Malta in 2012?
Offer a terse response. -1.42e+1. What is the difference between the Imports (BoP, current US$) in Grenada in 2008 and the Imports (BoP, current US$) in Nepal in 2012?
Keep it short and to the point. -6.40e+09. What is the difference between the Imports (BoP, current US$) of Macao in 2008 and the Imports (BoP, current US$) of Malta in 2012?
Keep it short and to the point. -1.57e+09. What is the difference between the Imports (BoP, current US$) in Macao in 2008 and the Imports (BoP, current US$) in Nepal in 2012?
Give a very brief answer. 6.27e+09. What is the difference between the Imports (BoP, current US$) in Malta in 2008 and the Imports (BoP, current US$) in Nepal in 2012?
Provide a short and direct response. 6.55e+09. What is the difference between the Imports (BoP, current US$) in Grenada in 2008 and the Imports (BoP, current US$) in Macao in 2013?
Provide a short and direct response. -2.33e+1. What is the difference between the Imports (BoP, current US$) of Grenada in 2008 and the Imports (BoP, current US$) of Malta in 2013?
Your answer should be very brief. -1.44e+1. What is the difference between the Imports (BoP, current US$) of Grenada in 2008 and the Imports (BoP, current US$) of Nepal in 2013?
Offer a very short reply. -7.08e+09. What is the difference between the Imports (BoP, current US$) of Macao in 2008 and the Imports (BoP, current US$) of Malta in 2013?
Offer a very short reply. -1.75e+09. What is the difference between the Imports (BoP, current US$) in Macao in 2008 and the Imports (BoP, current US$) in Nepal in 2013?
Make the answer very short. 5.59e+09. What is the difference between the Imports (BoP, current US$) in Malta in 2008 and the Imports (BoP, current US$) in Nepal in 2013?
Provide a succinct answer. 5.87e+09. What is the difference between the Imports (BoP, current US$) of Grenada in 2009 and the Imports (BoP, current US$) of Macao in 2010?
Your answer should be very brief. -1.38e+1. What is the difference between the Imports (BoP, current US$) in Grenada in 2009 and the Imports (BoP, current US$) in Malta in 2010?
Offer a very short reply. -1.31e+1. What is the difference between the Imports (BoP, current US$) of Grenada in 2009 and the Imports (BoP, current US$) of Nepal in 2010?
Your answer should be compact. -5.52e+09. What is the difference between the Imports (BoP, current US$) in Macao in 2009 and the Imports (BoP, current US$) in Malta in 2010?
Your answer should be compact. -2.89e+09. What is the difference between the Imports (BoP, current US$) of Macao in 2009 and the Imports (BoP, current US$) of Nepal in 2010?
Make the answer very short. 4.69e+09. What is the difference between the Imports (BoP, current US$) in Malta in 2009 and the Imports (BoP, current US$) in Nepal in 2010?
Keep it short and to the point. 6.89e+09. What is the difference between the Imports (BoP, current US$) of Grenada in 2009 and the Imports (BoP, current US$) of Macao in 2011?
Ensure brevity in your answer.  -1.92e+1. What is the difference between the Imports (BoP, current US$) in Grenada in 2009 and the Imports (BoP, current US$) in Malta in 2011?
Your answer should be very brief. -1.46e+1. What is the difference between the Imports (BoP, current US$) of Grenada in 2009 and the Imports (BoP, current US$) of Nepal in 2011?
Offer a very short reply. -6.09e+09. What is the difference between the Imports (BoP, current US$) of Macao in 2009 and the Imports (BoP, current US$) of Malta in 2011?
Your response must be concise. -4.39e+09. What is the difference between the Imports (BoP, current US$) of Macao in 2009 and the Imports (BoP, current US$) of Nepal in 2011?
Give a very brief answer. 4.12e+09. What is the difference between the Imports (BoP, current US$) of Malta in 2009 and the Imports (BoP, current US$) of Nepal in 2011?
Provide a succinct answer. 6.32e+09. What is the difference between the Imports (BoP, current US$) of Grenada in 2009 and the Imports (BoP, current US$) of Macao in 2012?
Give a very brief answer. -2.14e+1. What is the difference between the Imports (BoP, current US$) of Grenada in 2009 and the Imports (BoP, current US$) of Malta in 2012?
Ensure brevity in your answer.  -1.43e+1. What is the difference between the Imports (BoP, current US$) in Grenada in 2009 and the Imports (BoP, current US$) in Nepal in 2012?
Your answer should be compact. -6.49e+09. What is the difference between the Imports (BoP, current US$) of Macao in 2009 and the Imports (BoP, current US$) of Malta in 2012?
Ensure brevity in your answer.  -4.12e+09. What is the difference between the Imports (BoP, current US$) in Macao in 2009 and the Imports (BoP, current US$) in Nepal in 2012?
Keep it short and to the point. 3.72e+09. What is the difference between the Imports (BoP, current US$) in Malta in 2009 and the Imports (BoP, current US$) in Nepal in 2012?
Give a very brief answer. 5.92e+09. What is the difference between the Imports (BoP, current US$) of Grenada in 2009 and the Imports (BoP, current US$) of Macao in 2013?
Your answer should be compact. -2.33e+1. What is the difference between the Imports (BoP, current US$) of Grenada in 2009 and the Imports (BoP, current US$) of Malta in 2013?
Your answer should be very brief. -1.45e+1. What is the difference between the Imports (BoP, current US$) in Grenada in 2009 and the Imports (BoP, current US$) in Nepal in 2013?
Provide a succinct answer. -7.17e+09. What is the difference between the Imports (BoP, current US$) in Macao in 2009 and the Imports (BoP, current US$) in Malta in 2013?
Your response must be concise. -4.30e+09. What is the difference between the Imports (BoP, current US$) of Macao in 2009 and the Imports (BoP, current US$) of Nepal in 2013?
Make the answer very short. 3.04e+09. What is the difference between the Imports (BoP, current US$) of Malta in 2009 and the Imports (BoP, current US$) of Nepal in 2013?
Offer a terse response. 5.24e+09. What is the difference between the Imports (BoP, current US$) in Grenada in 2010 and the Imports (BoP, current US$) in Macao in 2011?
Provide a short and direct response. -1.92e+1. What is the difference between the Imports (BoP, current US$) in Grenada in 2010 and the Imports (BoP, current US$) in Malta in 2011?
Your answer should be compact. -1.46e+1. What is the difference between the Imports (BoP, current US$) in Grenada in 2010 and the Imports (BoP, current US$) in Nepal in 2011?
Your response must be concise. -6.07e+09. What is the difference between the Imports (BoP, current US$) in Macao in 2010 and the Imports (BoP, current US$) in Malta in 2011?
Provide a succinct answer. -8.31e+08. What is the difference between the Imports (BoP, current US$) of Macao in 2010 and the Imports (BoP, current US$) of Nepal in 2011?
Provide a succinct answer. 7.68e+09. What is the difference between the Imports (BoP, current US$) in Malta in 2010 and the Imports (BoP, current US$) in Nepal in 2011?
Your answer should be very brief. 7.01e+09. What is the difference between the Imports (BoP, current US$) of Grenada in 2010 and the Imports (BoP, current US$) of Macao in 2012?
Your answer should be compact. -2.14e+1. What is the difference between the Imports (BoP, current US$) of Grenada in 2010 and the Imports (BoP, current US$) of Malta in 2012?
Give a very brief answer. -1.43e+1. What is the difference between the Imports (BoP, current US$) of Grenada in 2010 and the Imports (BoP, current US$) of Nepal in 2012?
Make the answer very short. -6.47e+09. What is the difference between the Imports (BoP, current US$) in Macao in 2010 and the Imports (BoP, current US$) in Malta in 2012?
Your response must be concise. -5.58e+08. What is the difference between the Imports (BoP, current US$) of Macao in 2010 and the Imports (BoP, current US$) of Nepal in 2012?
Keep it short and to the point. 7.28e+09. What is the difference between the Imports (BoP, current US$) of Malta in 2010 and the Imports (BoP, current US$) of Nepal in 2012?
Offer a terse response. 6.61e+09. What is the difference between the Imports (BoP, current US$) in Grenada in 2010 and the Imports (BoP, current US$) in Macao in 2013?
Your response must be concise. -2.33e+1. What is the difference between the Imports (BoP, current US$) of Grenada in 2010 and the Imports (BoP, current US$) of Malta in 2013?
Provide a short and direct response. -1.45e+1. What is the difference between the Imports (BoP, current US$) of Grenada in 2010 and the Imports (BoP, current US$) of Nepal in 2013?
Provide a short and direct response. -7.15e+09. What is the difference between the Imports (BoP, current US$) of Macao in 2010 and the Imports (BoP, current US$) of Malta in 2013?
Offer a terse response. -7.35e+08. What is the difference between the Imports (BoP, current US$) in Macao in 2010 and the Imports (BoP, current US$) in Nepal in 2013?
Provide a short and direct response. 6.60e+09. What is the difference between the Imports (BoP, current US$) of Malta in 2010 and the Imports (BoP, current US$) of Nepal in 2013?
Keep it short and to the point. 5.93e+09. What is the difference between the Imports (BoP, current US$) of Grenada in 2011 and the Imports (BoP, current US$) of Macao in 2012?
Keep it short and to the point. -2.14e+1. What is the difference between the Imports (BoP, current US$) of Grenada in 2011 and the Imports (BoP, current US$) of Malta in 2012?
Keep it short and to the point. -1.43e+1. What is the difference between the Imports (BoP, current US$) of Grenada in 2011 and the Imports (BoP, current US$) of Nepal in 2012?
Keep it short and to the point. -6.45e+09. What is the difference between the Imports (BoP, current US$) in Macao in 2011 and the Imports (BoP, current US$) in Malta in 2012?
Your response must be concise. 4.89e+09. What is the difference between the Imports (BoP, current US$) of Macao in 2011 and the Imports (BoP, current US$) of Nepal in 2012?
Ensure brevity in your answer.  1.27e+1. What is the difference between the Imports (BoP, current US$) of Malta in 2011 and the Imports (BoP, current US$) of Nepal in 2012?
Offer a very short reply. 8.11e+09. What is the difference between the Imports (BoP, current US$) in Grenada in 2011 and the Imports (BoP, current US$) in Macao in 2013?
Ensure brevity in your answer.  -2.33e+1. What is the difference between the Imports (BoP, current US$) in Grenada in 2011 and the Imports (BoP, current US$) in Malta in 2013?
Provide a succinct answer. -1.45e+1. What is the difference between the Imports (BoP, current US$) in Grenada in 2011 and the Imports (BoP, current US$) in Nepal in 2013?
Keep it short and to the point. -7.13e+09. What is the difference between the Imports (BoP, current US$) of Macao in 2011 and the Imports (BoP, current US$) of Malta in 2013?
Offer a terse response. 4.71e+09. What is the difference between the Imports (BoP, current US$) in Macao in 2011 and the Imports (BoP, current US$) in Nepal in 2013?
Give a very brief answer. 1.20e+1. What is the difference between the Imports (BoP, current US$) of Malta in 2011 and the Imports (BoP, current US$) of Nepal in 2013?
Your answer should be compact. 7.43e+09. What is the difference between the Imports (BoP, current US$) of Grenada in 2012 and the Imports (BoP, current US$) of Macao in 2013?
Ensure brevity in your answer.  -2.33e+1. What is the difference between the Imports (BoP, current US$) in Grenada in 2012 and the Imports (BoP, current US$) in Malta in 2013?
Give a very brief answer. -1.45e+1. What is the difference between the Imports (BoP, current US$) of Grenada in 2012 and the Imports (BoP, current US$) of Nepal in 2013?
Ensure brevity in your answer.  -7.13e+09. What is the difference between the Imports (BoP, current US$) in Macao in 2012 and the Imports (BoP, current US$) in Malta in 2013?
Provide a succinct answer. 6.93e+09. What is the difference between the Imports (BoP, current US$) of Macao in 2012 and the Imports (BoP, current US$) of Nepal in 2013?
Provide a short and direct response. 1.43e+1. What is the difference between the Imports (BoP, current US$) of Malta in 2012 and the Imports (BoP, current US$) of Nepal in 2013?
Your answer should be compact. 7.16e+09. What is the average Imports (BoP, current US$) in Grenada per year?
Ensure brevity in your answer.  4.06e+08. What is the average Imports (BoP, current US$) in Macao per year?
Make the answer very short. 1.55e+1. What is the average Imports (BoP, current US$) in Malta per year?
Your response must be concise. 1.22e+1. What is the average Imports (BoP, current US$) of Nepal per year?
Keep it short and to the point. 5.35e+09. In the year 2006, what is the difference between the Imports (BoP, current US$) in Grenada and Imports (BoP, current US$) in Macao?
Your answer should be very brief. -8.52e+09. In the year 2006, what is the difference between the Imports (BoP, current US$) in Grenada and Imports (BoP, current US$) in Malta?
Your response must be concise. -5.81e+09. In the year 2006, what is the difference between the Imports (BoP, current US$) of Grenada and Imports (BoP, current US$) of Nepal?
Offer a terse response. -2.53e+09. In the year 2006, what is the difference between the Imports (BoP, current US$) of Macao and Imports (BoP, current US$) of Malta?
Provide a short and direct response. 2.71e+09. In the year 2006, what is the difference between the Imports (BoP, current US$) in Macao and Imports (BoP, current US$) in Nepal?
Your response must be concise. 5.99e+09. In the year 2006, what is the difference between the Imports (BoP, current US$) in Malta and Imports (BoP, current US$) in Nepal?
Provide a short and direct response. 3.28e+09. In the year 2007, what is the difference between the Imports (BoP, current US$) of Grenada and Imports (BoP, current US$) of Macao?
Offer a very short reply. -1.15e+1. In the year 2007, what is the difference between the Imports (BoP, current US$) of Grenada and Imports (BoP, current US$) of Malta?
Provide a short and direct response. -6.73e+09. In the year 2007, what is the difference between the Imports (BoP, current US$) in Grenada and Imports (BoP, current US$) in Nepal?
Ensure brevity in your answer.  -3.22e+09. In the year 2007, what is the difference between the Imports (BoP, current US$) of Macao and Imports (BoP, current US$) of Malta?
Give a very brief answer. 4.73e+09. In the year 2007, what is the difference between the Imports (BoP, current US$) of Macao and Imports (BoP, current US$) of Nepal?
Make the answer very short. 8.24e+09. In the year 2007, what is the difference between the Imports (BoP, current US$) of Malta and Imports (BoP, current US$) of Nepal?
Offer a terse response. 3.51e+09. In the year 2008, what is the difference between the Imports (BoP, current US$) of Grenada and Imports (BoP, current US$) of Macao?
Offer a terse response. -1.27e+1. In the year 2008, what is the difference between the Imports (BoP, current US$) of Grenada and Imports (BoP, current US$) of Malta?
Ensure brevity in your answer.  -1.29e+1. In the year 2008, what is the difference between the Imports (BoP, current US$) in Grenada and Imports (BoP, current US$) in Nepal?
Provide a succinct answer. -3.92e+09. In the year 2008, what is the difference between the Imports (BoP, current US$) in Macao and Imports (BoP, current US$) in Malta?
Make the answer very short. -2.83e+08. In the year 2008, what is the difference between the Imports (BoP, current US$) of Macao and Imports (BoP, current US$) of Nepal?
Keep it short and to the point. 8.74e+09. In the year 2008, what is the difference between the Imports (BoP, current US$) in Malta and Imports (BoP, current US$) in Nepal?
Make the answer very short. 9.03e+09. In the year 2009, what is the difference between the Imports (BoP, current US$) of Grenada and Imports (BoP, current US$) of Macao?
Provide a succinct answer. -1.02e+1. In the year 2009, what is the difference between the Imports (BoP, current US$) of Grenada and Imports (BoP, current US$) of Malta?
Ensure brevity in your answer.  -1.24e+1. In the year 2009, what is the difference between the Imports (BoP, current US$) of Grenada and Imports (BoP, current US$) of Nepal?
Provide a succinct answer. -4.74e+09. In the year 2009, what is the difference between the Imports (BoP, current US$) of Macao and Imports (BoP, current US$) of Malta?
Your answer should be very brief. -2.20e+09. In the year 2009, what is the difference between the Imports (BoP, current US$) of Macao and Imports (BoP, current US$) of Nepal?
Your response must be concise. 5.47e+09. In the year 2009, what is the difference between the Imports (BoP, current US$) in Malta and Imports (BoP, current US$) in Nepal?
Keep it short and to the point. 7.67e+09. In the year 2010, what is the difference between the Imports (BoP, current US$) of Grenada and Imports (BoP, current US$) of Macao?
Provide a short and direct response. -1.38e+1. In the year 2010, what is the difference between the Imports (BoP, current US$) of Grenada and Imports (BoP, current US$) of Malta?
Ensure brevity in your answer.  -1.31e+1. In the year 2010, what is the difference between the Imports (BoP, current US$) in Grenada and Imports (BoP, current US$) in Nepal?
Your answer should be compact. -5.50e+09. In the year 2010, what is the difference between the Imports (BoP, current US$) in Macao and Imports (BoP, current US$) in Malta?
Offer a terse response. 6.73e+08. In the year 2010, what is the difference between the Imports (BoP, current US$) of Macao and Imports (BoP, current US$) of Nepal?
Make the answer very short. 8.25e+09. In the year 2010, what is the difference between the Imports (BoP, current US$) of Malta and Imports (BoP, current US$) of Nepal?
Your answer should be compact. 7.58e+09. In the year 2011, what is the difference between the Imports (BoP, current US$) of Grenada and Imports (BoP, current US$) of Macao?
Offer a very short reply. -1.92e+1. In the year 2011, what is the difference between the Imports (BoP, current US$) of Grenada and Imports (BoP, current US$) of Malta?
Make the answer very short. -1.46e+1. In the year 2011, what is the difference between the Imports (BoP, current US$) of Grenada and Imports (BoP, current US$) of Nepal?
Offer a very short reply. -6.05e+09. In the year 2011, what is the difference between the Imports (BoP, current US$) of Macao and Imports (BoP, current US$) of Malta?
Give a very brief answer. 4.62e+09. In the year 2011, what is the difference between the Imports (BoP, current US$) in Macao and Imports (BoP, current US$) in Nepal?
Ensure brevity in your answer.  1.31e+1. In the year 2011, what is the difference between the Imports (BoP, current US$) of Malta and Imports (BoP, current US$) of Nepal?
Offer a terse response. 8.51e+09. In the year 2012, what is the difference between the Imports (BoP, current US$) in Grenada and Imports (BoP, current US$) in Macao?
Offer a very short reply. -2.14e+1. In the year 2012, what is the difference between the Imports (BoP, current US$) in Grenada and Imports (BoP, current US$) in Malta?
Offer a very short reply. -1.43e+1. In the year 2012, what is the difference between the Imports (BoP, current US$) in Grenada and Imports (BoP, current US$) in Nepal?
Your answer should be compact. -6.45e+09. In the year 2012, what is the difference between the Imports (BoP, current US$) of Macao and Imports (BoP, current US$) of Malta?
Your response must be concise. 7.11e+09. In the year 2012, what is the difference between the Imports (BoP, current US$) of Macao and Imports (BoP, current US$) of Nepal?
Your answer should be very brief. 1.50e+1. In the year 2012, what is the difference between the Imports (BoP, current US$) of Malta and Imports (BoP, current US$) of Nepal?
Give a very brief answer. 7.84e+09. In the year 2013, what is the difference between the Imports (BoP, current US$) in Grenada and Imports (BoP, current US$) in Macao?
Keep it short and to the point. -2.33e+1. In the year 2013, what is the difference between the Imports (BoP, current US$) in Grenada and Imports (BoP, current US$) in Malta?
Provide a short and direct response. -1.44e+1. In the year 2013, what is the difference between the Imports (BoP, current US$) in Grenada and Imports (BoP, current US$) in Nepal?
Your answer should be compact. -7.10e+09. In the year 2013, what is the difference between the Imports (BoP, current US$) of Macao and Imports (BoP, current US$) of Malta?
Give a very brief answer. 8.84e+09. In the year 2013, what is the difference between the Imports (BoP, current US$) in Macao and Imports (BoP, current US$) in Nepal?
Offer a terse response. 1.62e+1. In the year 2013, what is the difference between the Imports (BoP, current US$) in Malta and Imports (BoP, current US$) in Nepal?
Provide a succinct answer. 7.34e+09. What is the ratio of the Imports (BoP, current US$) of Grenada in 2006 to that in 2007?
Your answer should be compact. 0.92. What is the ratio of the Imports (BoP, current US$) in Macao in 2006 to that in 2007?
Make the answer very short. 0.75. What is the ratio of the Imports (BoP, current US$) of Malta in 2006 to that in 2007?
Your response must be concise. 0.87. What is the ratio of the Imports (BoP, current US$) of Nepal in 2006 to that in 2007?
Your answer should be compact. 0.8. What is the ratio of the Imports (BoP, current US$) of Grenada in 2006 to that in 2008?
Your response must be concise. 0.89. What is the ratio of the Imports (BoP, current US$) in Macao in 2006 to that in 2008?
Your answer should be very brief. 0.68. What is the ratio of the Imports (BoP, current US$) in Malta in 2006 to that in 2008?
Your answer should be very brief. 0.46. What is the ratio of the Imports (BoP, current US$) of Nepal in 2006 to that in 2008?
Offer a terse response. 0.67. What is the ratio of the Imports (BoP, current US$) in Grenada in 2006 to that in 2009?
Provide a succinct answer. 1.11. What is the ratio of the Imports (BoP, current US$) in Macao in 2006 to that in 2009?
Your answer should be very brief. 0.84. What is the ratio of the Imports (BoP, current US$) in Malta in 2006 to that in 2009?
Provide a short and direct response. 0.49. What is the ratio of the Imports (BoP, current US$) of Nepal in 2006 to that in 2009?
Make the answer very short. 0.58. What is the ratio of the Imports (BoP, current US$) of Grenada in 2006 to that in 2010?
Your answer should be very brief. 1.06. What is the ratio of the Imports (BoP, current US$) in Macao in 2006 to that in 2010?
Keep it short and to the point. 0.63. What is the ratio of the Imports (BoP, current US$) of Malta in 2006 to that in 2010?
Offer a terse response. 0.46. What is the ratio of the Imports (BoP, current US$) in Nepal in 2006 to that in 2010?
Provide a succinct answer. 0.5. What is the ratio of the Imports (BoP, current US$) of Grenada in 2006 to that in 2011?
Keep it short and to the point. 1.02. What is the ratio of the Imports (BoP, current US$) of Macao in 2006 to that in 2011?
Give a very brief answer. 0.46. What is the ratio of the Imports (BoP, current US$) of Malta in 2006 to that in 2011?
Give a very brief answer. 0.42. What is the ratio of the Imports (BoP, current US$) of Nepal in 2006 to that in 2011?
Ensure brevity in your answer.  0.46. What is the ratio of the Imports (BoP, current US$) in Macao in 2006 to that in 2012?
Offer a very short reply. 0.41. What is the ratio of the Imports (BoP, current US$) in Malta in 2006 to that in 2012?
Your answer should be compact. 0.42. What is the ratio of the Imports (BoP, current US$) in Nepal in 2006 to that in 2012?
Make the answer very short. 0.43. What is the ratio of the Imports (BoP, current US$) in Grenada in 2006 to that in 2013?
Offer a very short reply. 0.95. What is the ratio of the Imports (BoP, current US$) in Macao in 2006 to that in 2013?
Offer a very short reply. 0.38. What is the ratio of the Imports (BoP, current US$) in Malta in 2006 to that in 2013?
Provide a short and direct response. 0.42. What is the ratio of the Imports (BoP, current US$) of Nepal in 2006 to that in 2013?
Make the answer very short. 0.39. What is the ratio of the Imports (BoP, current US$) in Grenada in 2007 to that in 2008?
Offer a terse response. 0.97. What is the ratio of the Imports (BoP, current US$) of Macao in 2007 to that in 2008?
Give a very brief answer. 0.91. What is the ratio of the Imports (BoP, current US$) in Malta in 2007 to that in 2008?
Give a very brief answer. 0.53. What is the ratio of the Imports (BoP, current US$) in Nepal in 2007 to that in 2008?
Provide a succinct answer. 0.84. What is the ratio of the Imports (BoP, current US$) in Grenada in 2007 to that in 2009?
Ensure brevity in your answer.  1.21. What is the ratio of the Imports (BoP, current US$) in Macao in 2007 to that in 2009?
Your answer should be compact. 1.13. What is the ratio of the Imports (BoP, current US$) of Malta in 2007 to that in 2009?
Offer a very short reply. 0.56. What is the ratio of the Imports (BoP, current US$) of Nepal in 2007 to that in 2009?
Offer a very short reply. 0.72. What is the ratio of the Imports (BoP, current US$) of Grenada in 2007 to that in 2010?
Your answer should be compact. 1.15. What is the ratio of the Imports (BoP, current US$) of Macao in 2007 to that in 2010?
Offer a terse response. 0.84. What is the ratio of the Imports (BoP, current US$) in Malta in 2007 to that in 2010?
Offer a very short reply. 0.53. What is the ratio of the Imports (BoP, current US$) of Nepal in 2007 to that in 2010?
Your response must be concise. 0.62. What is the ratio of the Imports (BoP, current US$) in Grenada in 2007 to that in 2011?
Your response must be concise. 1.1. What is the ratio of the Imports (BoP, current US$) of Macao in 2007 to that in 2011?
Your answer should be compact. 0.61. What is the ratio of the Imports (BoP, current US$) of Malta in 2007 to that in 2011?
Your answer should be compact. 0.48. What is the ratio of the Imports (BoP, current US$) of Nepal in 2007 to that in 2011?
Provide a succinct answer. 0.57. What is the ratio of the Imports (BoP, current US$) of Grenada in 2007 to that in 2012?
Make the answer very short. 1.1. What is the ratio of the Imports (BoP, current US$) in Macao in 2007 to that in 2012?
Keep it short and to the point. 0.55. What is the ratio of the Imports (BoP, current US$) of Malta in 2007 to that in 2012?
Provide a succinct answer. 0.49. What is the ratio of the Imports (BoP, current US$) of Nepal in 2007 to that in 2012?
Offer a very short reply. 0.53. What is the ratio of the Imports (BoP, current US$) of Grenada in 2007 to that in 2013?
Make the answer very short. 1.03. What is the ratio of the Imports (BoP, current US$) in Macao in 2007 to that in 2013?
Ensure brevity in your answer.  0.5. What is the ratio of the Imports (BoP, current US$) in Malta in 2007 to that in 2013?
Provide a succinct answer. 0.48. What is the ratio of the Imports (BoP, current US$) in Nepal in 2007 to that in 2013?
Provide a succinct answer. 0.49. What is the ratio of the Imports (BoP, current US$) in Grenada in 2008 to that in 2009?
Make the answer very short. 1.25. What is the ratio of the Imports (BoP, current US$) in Macao in 2008 to that in 2009?
Provide a succinct answer. 1.24. What is the ratio of the Imports (BoP, current US$) of Malta in 2008 to that in 2009?
Offer a very short reply. 1.05. What is the ratio of the Imports (BoP, current US$) in Nepal in 2008 to that in 2009?
Your response must be concise. 0.86. What is the ratio of the Imports (BoP, current US$) of Grenada in 2008 to that in 2010?
Provide a short and direct response. 1.19. What is the ratio of the Imports (BoP, current US$) in Macao in 2008 to that in 2010?
Make the answer very short. 0.93. What is the ratio of the Imports (BoP, current US$) of Malta in 2008 to that in 2010?
Give a very brief answer. 1. What is the ratio of the Imports (BoP, current US$) of Nepal in 2008 to that in 2010?
Ensure brevity in your answer.  0.74. What is the ratio of the Imports (BoP, current US$) of Grenada in 2008 to that in 2011?
Give a very brief answer. 1.14. What is the ratio of the Imports (BoP, current US$) in Macao in 2008 to that in 2011?
Make the answer very short. 0.67. What is the ratio of the Imports (BoP, current US$) of Malta in 2008 to that in 2011?
Make the answer very short. 0.9. What is the ratio of the Imports (BoP, current US$) in Nepal in 2008 to that in 2011?
Make the answer very short. 0.68. What is the ratio of the Imports (BoP, current US$) of Grenada in 2008 to that in 2012?
Provide a succinct answer. 1.14. What is the ratio of the Imports (BoP, current US$) of Macao in 2008 to that in 2012?
Offer a very short reply. 0.6. What is the ratio of the Imports (BoP, current US$) in Malta in 2008 to that in 2012?
Offer a terse response. 0.91. What is the ratio of the Imports (BoP, current US$) in Nepal in 2008 to that in 2012?
Your answer should be compact. 0.64. What is the ratio of the Imports (BoP, current US$) of Grenada in 2008 to that in 2013?
Ensure brevity in your answer.  1.07. What is the ratio of the Imports (BoP, current US$) in Macao in 2008 to that in 2013?
Provide a short and direct response. 0.55. What is the ratio of the Imports (BoP, current US$) of Malta in 2008 to that in 2013?
Provide a short and direct response. 0.9. What is the ratio of the Imports (BoP, current US$) in Nepal in 2008 to that in 2013?
Offer a very short reply. 0.58. What is the ratio of the Imports (BoP, current US$) of Grenada in 2009 to that in 2010?
Provide a succinct answer. 0.95. What is the ratio of the Imports (BoP, current US$) of Macao in 2009 to that in 2010?
Ensure brevity in your answer.  0.75. What is the ratio of the Imports (BoP, current US$) of Malta in 2009 to that in 2010?
Your response must be concise. 0.95. What is the ratio of the Imports (BoP, current US$) of Nepal in 2009 to that in 2010?
Give a very brief answer. 0.87. What is the ratio of the Imports (BoP, current US$) of Grenada in 2009 to that in 2011?
Keep it short and to the point. 0.91. What is the ratio of the Imports (BoP, current US$) in Macao in 2009 to that in 2011?
Offer a terse response. 0.54. What is the ratio of the Imports (BoP, current US$) in Malta in 2009 to that in 2011?
Your answer should be compact. 0.85. What is the ratio of the Imports (BoP, current US$) in Nepal in 2009 to that in 2011?
Ensure brevity in your answer.  0.79. What is the ratio of the Imports (BoP, current US$) in Grenada in 2009 to that in 2012?
Provide a short and direct response. 0.91. What is the ratio of the Imports (BoP, current US$) of Macao in 2009 to that in 2012?
Give a very brief answer. 0.48. What is the ratio of the Imports (BoP, current US$) of Malta in 2009 to that in 2012?
Provide a succinct answer. 0.87. What is the ratio of the Imports (BoP, current US$) of Nepal in 2009 to that in 2012?
Your response must be concise. 0.74. What is the ratio of the Imports (BoP, current US$) in Grenada in 2009 to that in 2013?
Keep it short and to the point. 0.85. What is the ratio of the Imports (BoP, current US$) in Macao in 2009 to that in 2013?
Your response must be concise. 0.45. What is the ratio of the Imports (BoP, current US$) of Malta in 2009 to that in 2013?
Provide a short and direct response. 0.86. What is the ratio of the Imports (BoP, current US$) in Nepal in 2009 to that in 2013?
Make the answer very short. 0.68. What is the ratio of the Imports (BoP, current US$) of Grenada in 2010 to that in 2011?
Ensure brevity in your answer.  0.96. What is the ratio of the Imports (BoP, current US$) of Macao in 2010 to that in 2011?
Offer a terse response. 0.72. What is the ratio of the Imports (BoP, current US$) in Malta in 2010 to that in 2011?
Provide a short and direct response. 0.9. What is the ratio of the Imports (BoP, current US$) in Nepal in 2010 to that in 2011?
Ensure brevity in your answer.  0.91. What is the ratio of the Imports (BoP, current US$) of Grenada in 2010 to that in 2012?
Make the answer very short. 0.96. What is the ratio of the Imports (BoP, current US$) in Macao in 2010 to that in 2012?
Give a very brief answer. 0.65. What is the ratio of the Imports (BoP, current US$) of Malta in 2010 to that in 2012?
Your answer should be very brief. 0.92. What is the ratio of the Imports (BoP, current US$) of Nepal in 2010 to that in 2012?
Provide a succinct answer. 0.86. What is the ratio of the Imports (BoP, current US$) in Grenada in 2010 to that in 2013?
Ensure brevity in your answer.  0.9. What is the ratio of the Imports (BoP, current US$) in Macao in 2010 to that in 2013?
Keep it short and to the point. 0.6. What is the ratio of the Imports (BoP, current US$) in Malta in 2010 to that in 2013?
Your answer should be very brief. 0.91. What is the ratio of the Imports (BoP, current US$) of Nepal in 2010 to that in 2013?
Your answer should be very brief. 0.78. What is the ratio of the Imports (BoP, current US$) of Grenada in 2011 to that in 2012?
Provide a short and direct response. 1. What is the ratio of the Imports (BoP, current US$) in Macao in 2011 to that in 2012?
Your answer should be compact. 0.9. What is the ratio of the Imports (BoP, current US$) of Malta in 2011 to that in 2012?
Your response must be concise. 1.02. What is the ratio of the Imports (BoP, current US$) of Nepal in 2011 to that in 2012?
Your answer should be very brief. 0.94. What is the ratio of the Imports (BoP, current US$) of Grenada in 2011 to that in 2013?
Your response must be concise. 0.93. What is the ratio of the Imports (BoP, current US$) of Macao in 2011 to that in 2013?
Provide a succinct answer. 0.83. What is the ratio of the Imports (BoP, current US$) of Malta in 2011 to that in 2013?
Your answer should be very brief. 1.01. What is the ratio of the Imports (BoP, current US$) of Nepal in 2011 to that in 2013?
Keep it short and to the point. 0.86. What is the ratio of the Imports (BoP, current US$) in Grenada in 2012 to that in 2013?
Give a very brief answer. 0.93. What is the ratio of the Imports (BoP, current US$) in Macao in 2012 to that in 2013?
Keep it short and to the point. 0.92. What is the ratio of the Imports (BoP, current US$) in Malta in 2012 to that in 2013?
Your response must be concise. 0.99. What is the ratio of the Imports (BoP, current US$) of Nepal in 2012 to that in 2013?
Offer a terse response. 0.91. What is the difference between the highest and the second highest Imports (BoP, current US$) of Grenada?
Keep it short and to the point. 1.53e+07. What is the difference between the highest and the second highest Imports (BoP, current US$) in Macao?
Your answer should be compact. 1.91e+09. What is the difference between the highest and the second highest Imports (BoP, current US$) of Malta?
Make the answer very short. 9.62e+07. What is the difference between the highest and the second highest Imports (BoP, current US$) of Nepal?
Offer a terse response. 6.80e+08. What is the difference between the highest and the lowest Imports (BoP, current US$) of Grenada?
Give a very brief answer. 9.08e+07. What is the difference between the highest and the lowest Imports (BoP, current US$) in Macao?
Provide a succinct answer. 1.48e+1. What is the difference between the highest and the lowest Imports (BoP, current US$) of Malta?
Make the answer very short. 8.75e+09. What is the difference between the highest and the lowest Imports (BoP, current US$) in Nepal?
Your answer should be very brief. 4.59e+09. 